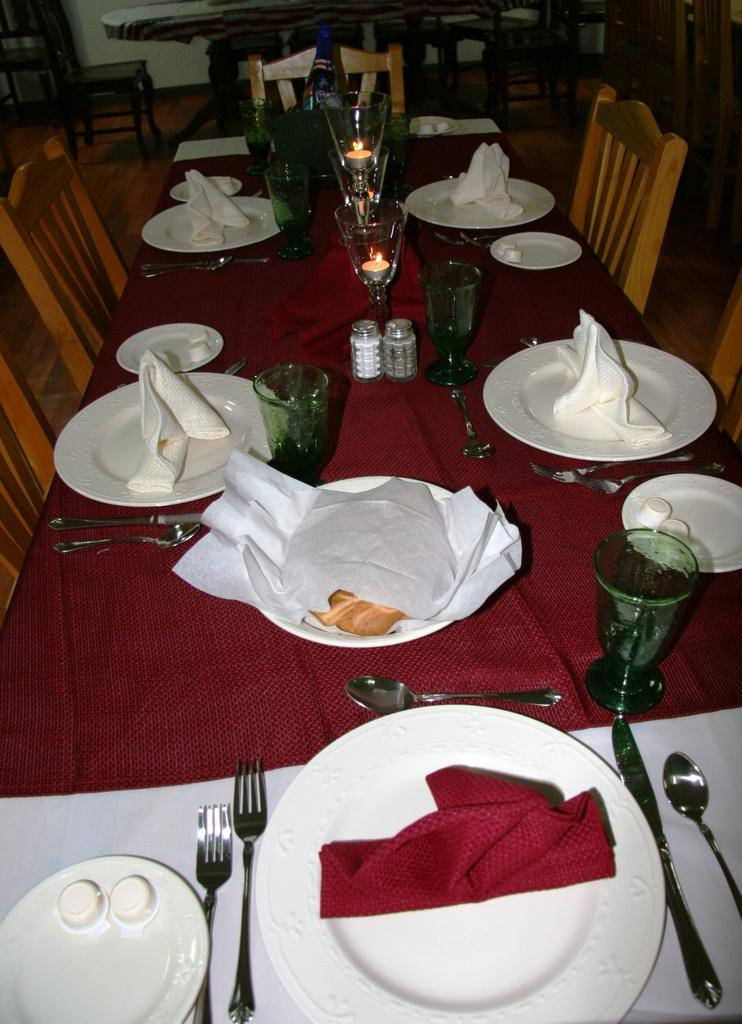What type of furniture is in the image? The image contains a table. What accompanies the table in the image? There are chairs around the table. What items are on the table? Plates, forks, spoons, knives, glasses, tissues, napkins, candles, salt, and pepper are visible on the table. What type of bone is visible on the table in the image? There is no bone present on the table in the image. What type of minister is depicted in the image? There is no minister depicted in the image; it features a table with various items on it. 